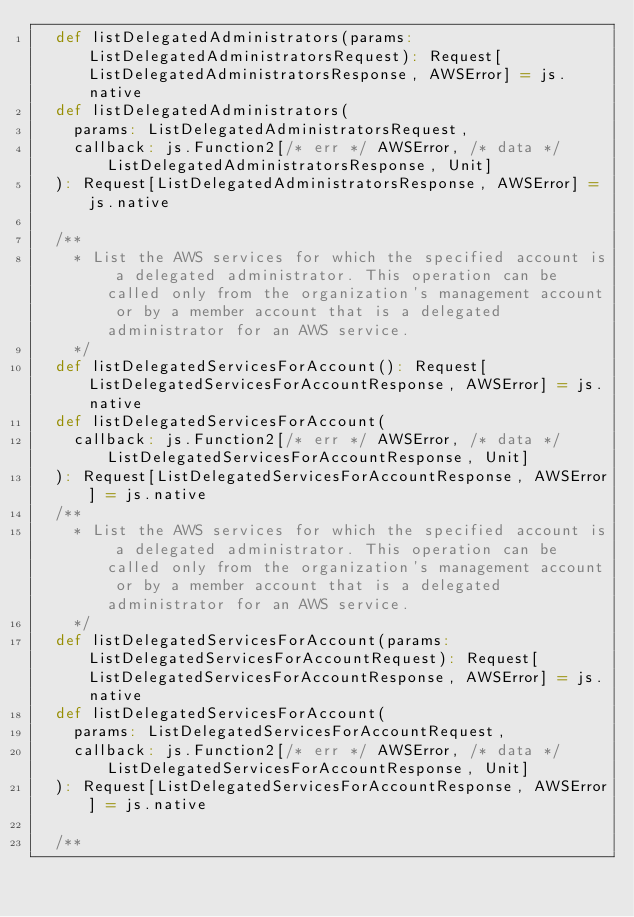Convert code to text. <code><loc_0><loc_0><loc_500><loc_500><_Scala_>  def listDelegatedAdministrators(params: ListDelegatedAdministratorsRequest): Request[ListDelegatedAdministratorsResponse, AWSError] = js.native
  def listDelegatedAdministrators(
    params: ListDelegatedAdministratorsRequest,
    callback: js.Function2[/* err */ AWSError, /* data */ ListDelegatedAdministratorsResponse, Unit]
  ): Request[ListDelegatedAdministratorsResponse, AWSError] = js.native
  
  /**
    * List the AWS services for which the specified account is a delegated administrator. This operation can be called only from the organization's management account or by a member account that is a delegated administrator for an AWS service.
    */
  def listDelegatedServicesForAccount(): Request[ListDelegatedServicesForAccountResponse, AWSError] = js.native
  def listDelegatedServicesForAccount(
    callback: js.Function2[/* err */ AWSError, /* data */ ListDelegatedServicesForAccountResponse, Unit]
  ): Request[ListDelegatedServicesForAccountResponse, AWSError] = js.native
  /**
    * List the AWS services for which the specified account is a delegated administrator. This operation can be called only from the organization's management account or by a member account that is a delegated administrator for an AWS service.
    */
  def listDelegatedServicesForAccount(params: ListDelegatedServicesForAccountRequest): Request[ListDelegatedServicesForAccountResponse, AWSError] = js.native
  def listDelegatedServicesForAccount(
    params: ListDelegatedServicesForAccountRequest,
    callback: js.Function2[/* err */ AWSError, /* data */ ListDelegatedServicesForAccountResponse, Unit]
  ): Request[ListDelegatedServicesForAccountResponse, AWSError] = js.native
  
  /**</code> 